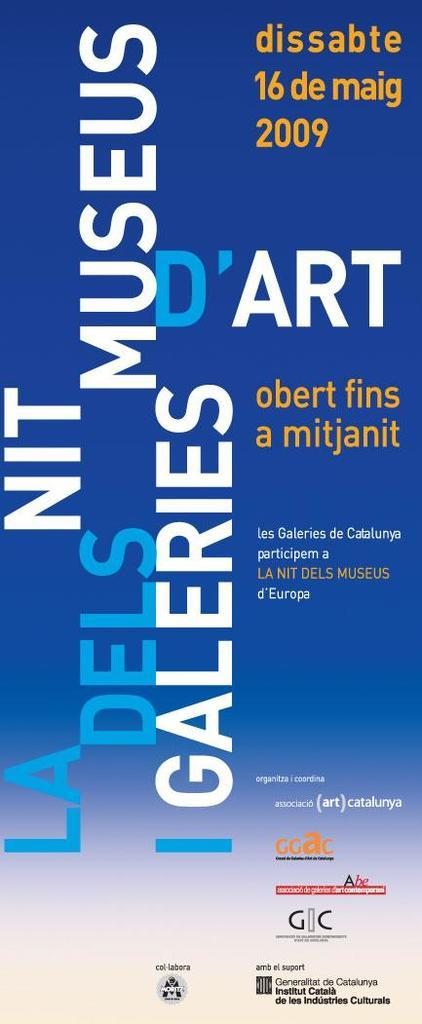<image>
Share a concise interpretation of the image provided. Poster for an event that takes place in 2009 on the 16th. 